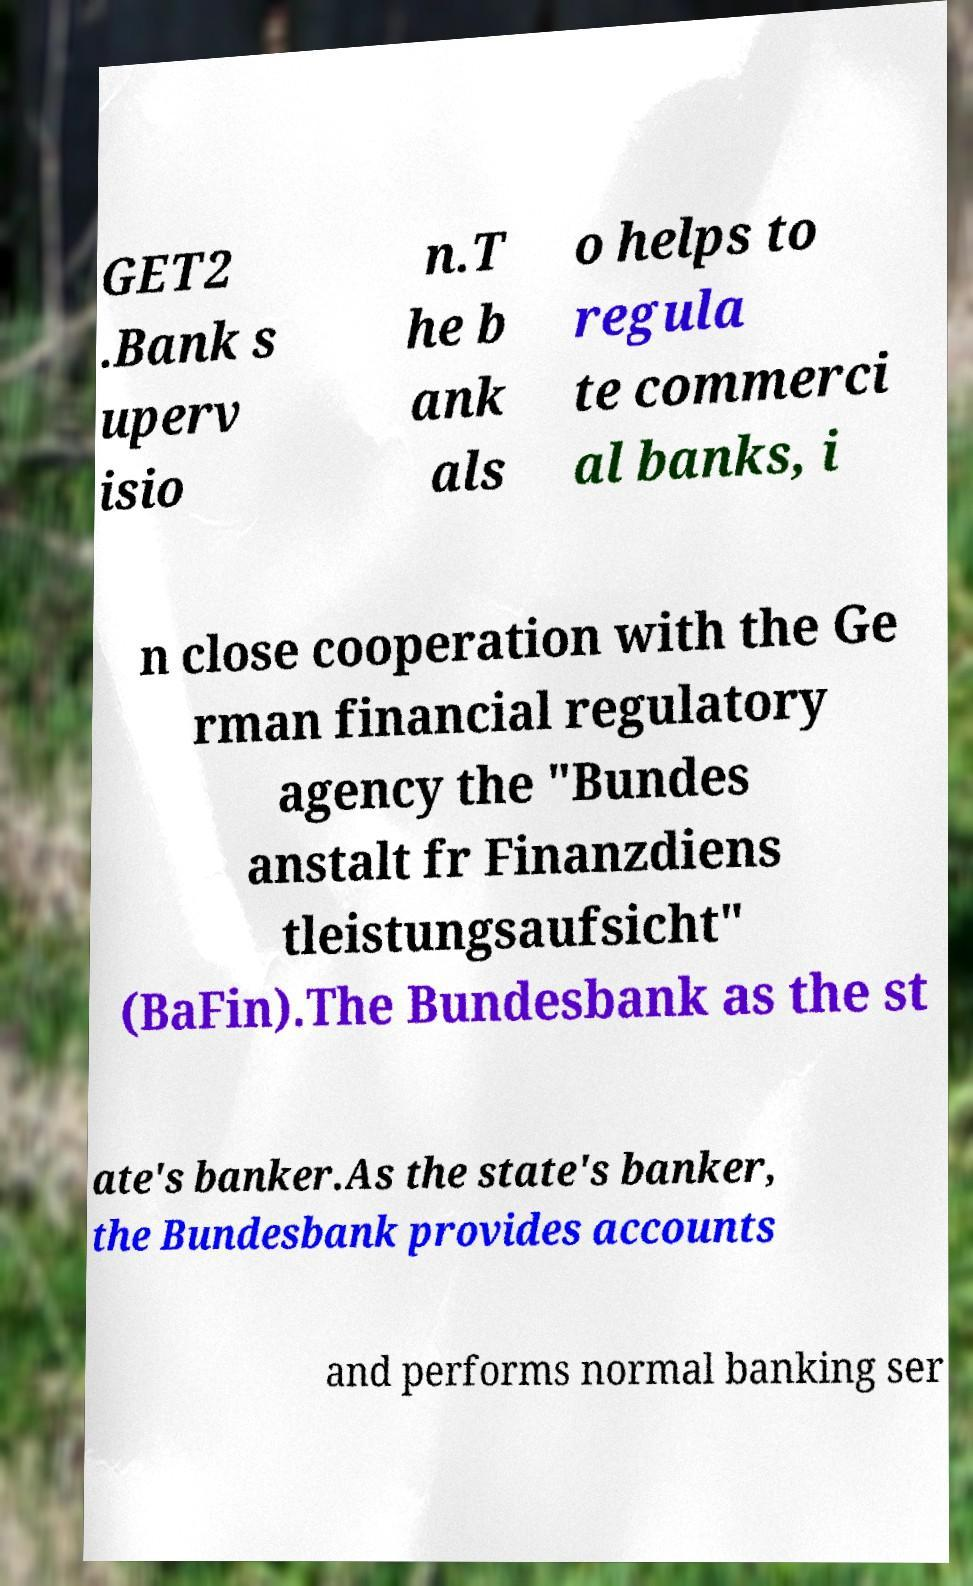There's text embedded in this image that I need extracted. Can you transcribe it verbatim? GET2 .Bank s uperv isio n.T he b ank als o helps to regula te commerci al banks, i n close cooperation with the Ge rman financial regulatory agency the "Bundes anstalt fr Finanzdiens tleistungsaufsicht" (BaFin).The Bundesbank as the st ate's banker.As the state's banker, the Bundesbank provides accounts and performs normal banking ser 